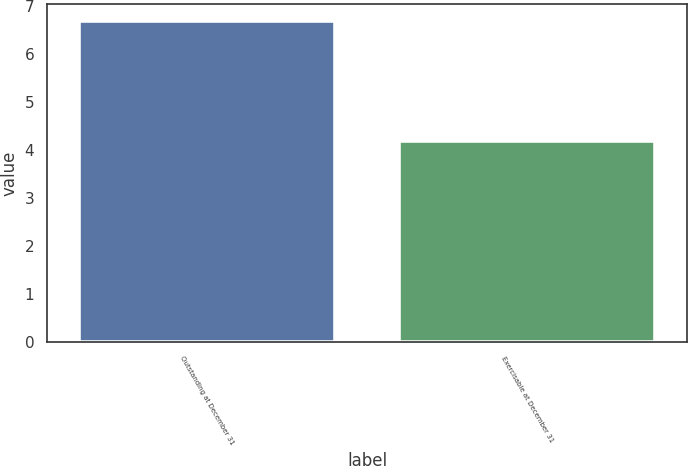Convert chart to OTSL. <chart><loc_0><loc_0><loc_500><loc_500><bar_chart><fcel>Outstanding at December 31<fcel>Exercisable at December 31<nl><fcel>6.7<fcel>4.2<nl></chart> 